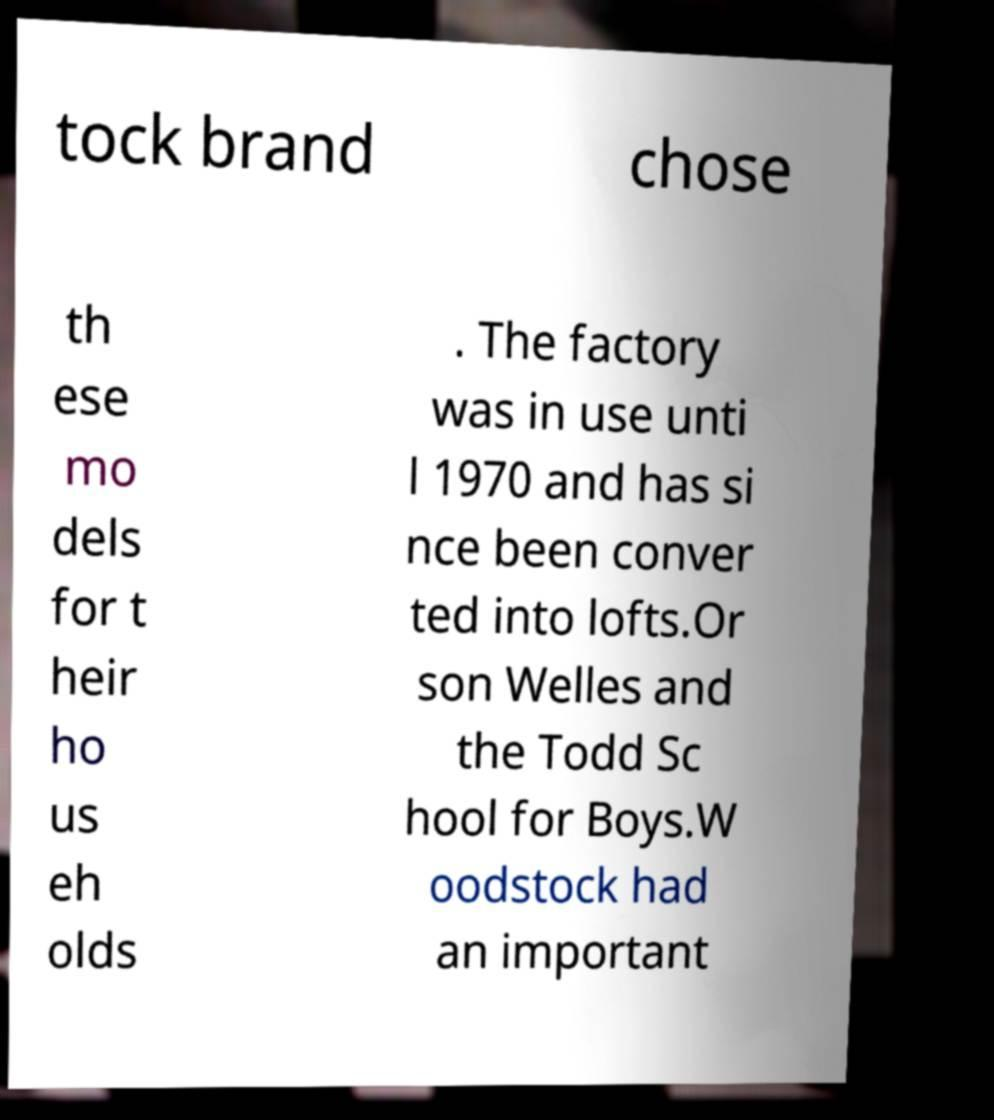For documentation purposes, I need the text within this image transcribed. Could you provide that? tock brand chose th ese mo dels for t heir ho us eh olds . The factory was in use unti l 1970 and has si nce been conver ted into lofts.Or son Welles and the Todd Sc hool for Boys.W oodstock had an important 